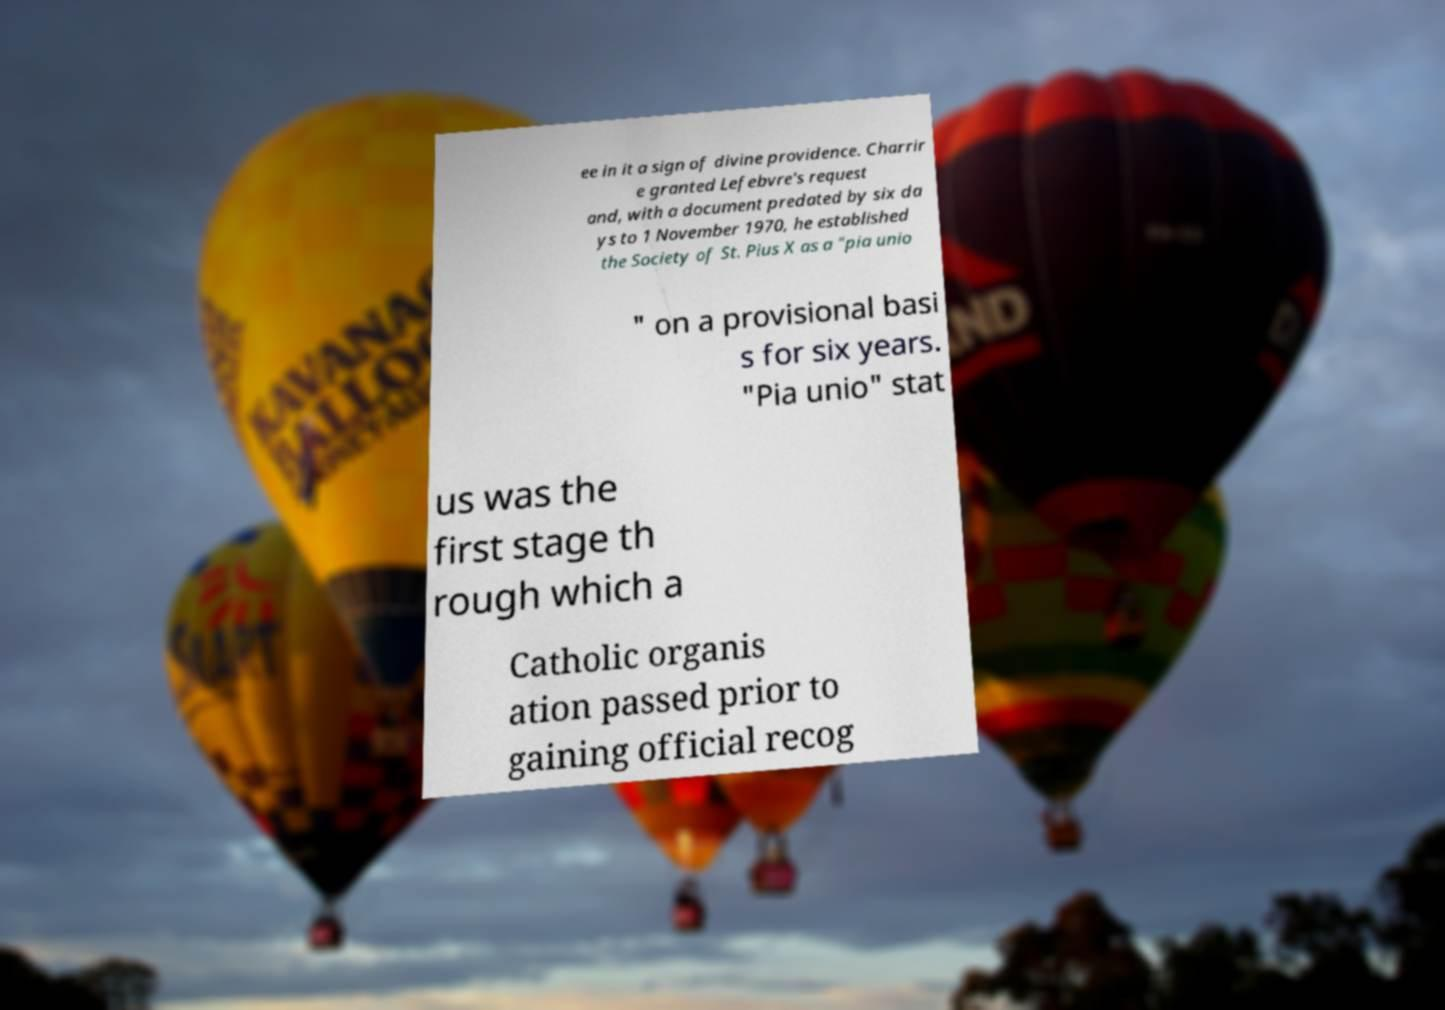Can you read and provide the text displayed in the image?This photo seems to have some interesting text. Can you extract and type it out for me? ee in it a sign of divine providence. Charrir e granted Lefebvre's request and, with a document predated by six da ys to 1 November 1970, he established the Society of St. Pius X as a "pia unio " on a provisional basi s for six years. "Pia unio" stat us was the first stage th rough which a Catholic organis ation passed prior to gaining official recog 